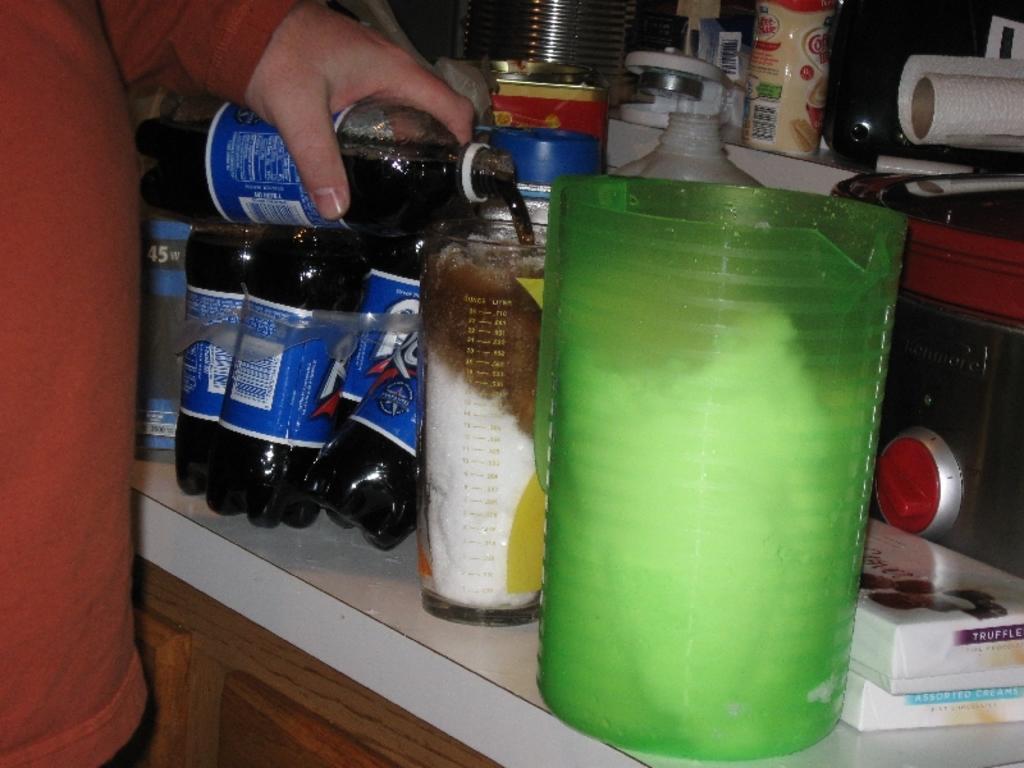Describe this image in one or two sentences. In this image I can see bottles,glass,containers and some objects on the counter top and one person is holding the bottle. 